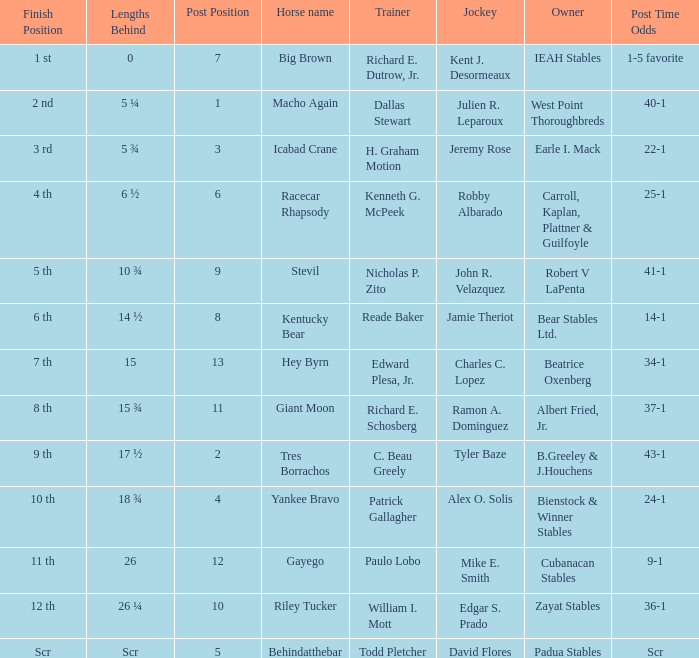What is the extent of jeremy rose's length? 5 ¾. 